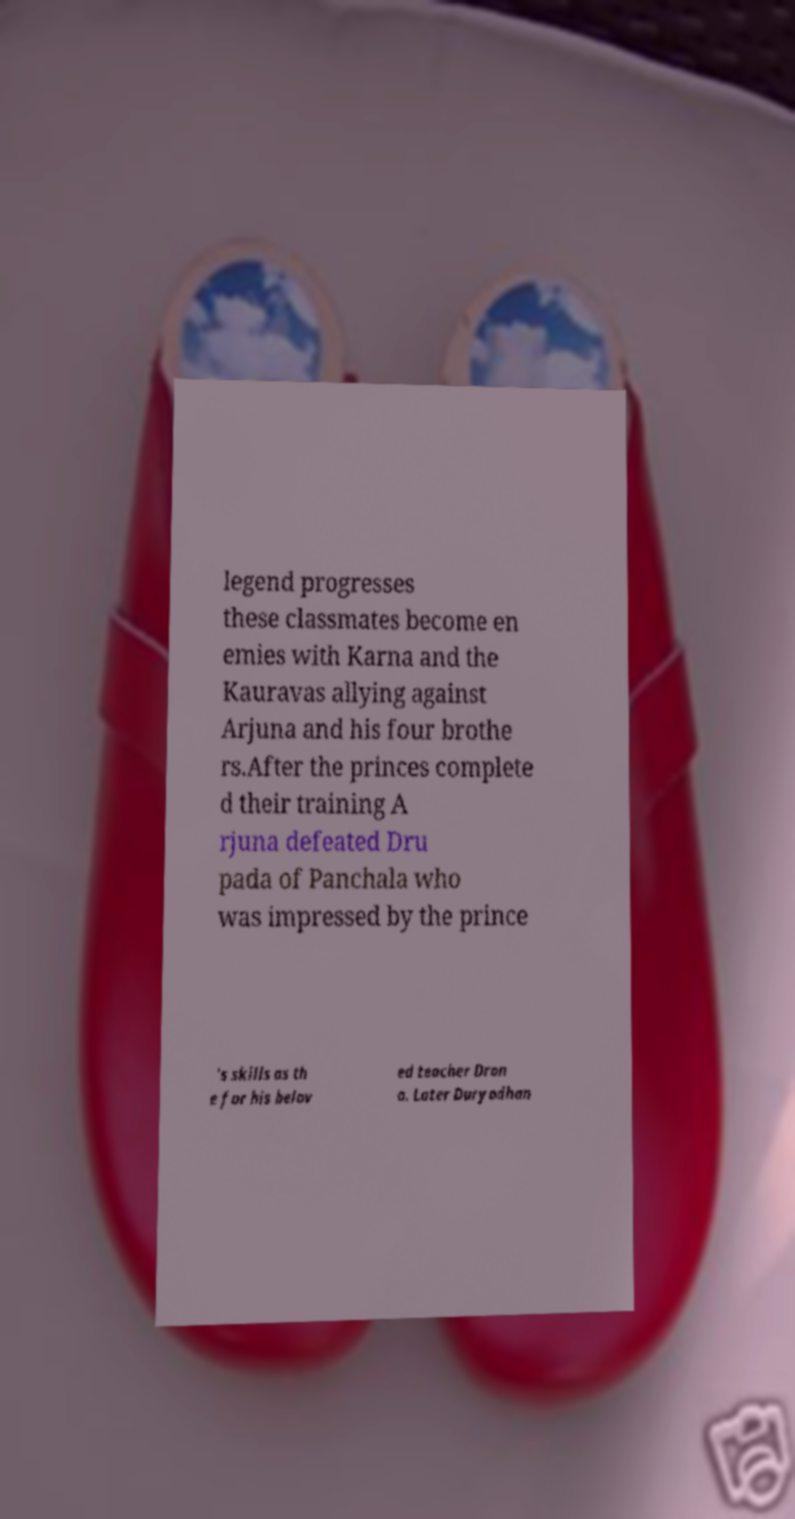Please read and relay the text visible in this image. What does it say? legend progresses these classmates become en emies with Karna and the Kauravas allying against Arjuna and his four brothe rs.After the princes complete d their training A rjuna defeated Dru pada of Panchala who was impressed by the prince 's skills as th e for his belov ed teacher Dron a. Later Duryodhan 